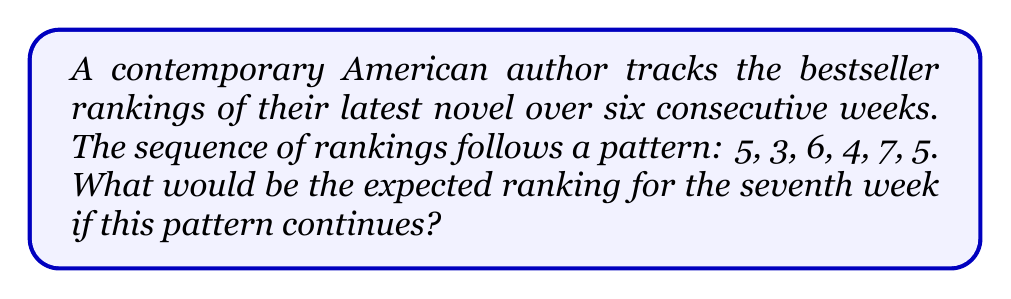Provide a solution to this math problem. To solve this sequence problem, let's analyze the pattern:

1. First, we'll calculate the differences between consecutive terms:
   $5 \rightarrow 3$ (difference: -2)
   $3 \rightarrow 6$ (difference: +3)
   $6 \rightarrow 4$ (difference: -2)
   $4 \rightarrow 7$ (difference: +3)
   $7 \rightarrow 5$ (difference: -2)

2. We can observe that the differences alternate between -2 and +3.

3. The sequence can be represented as:
   $$a_n = \begin{cases}
   a_{n-2} - 2 & \text{if } n \text{ is odd} \\
   a_{n-2} + 3 & \text{if } n \text{ is even}
   \end{cases}$$

4. Since we're looking for the 7th term (an odd number), we'll use the first case of the equation:
   $a_7 = a_5 - 2$

5. We know that $a_5 = 7$, so:
   $a_7 = 7 - 2 = 5$

Therefore, the expected ranking for the seventh week would be 5.
Answer: 5 